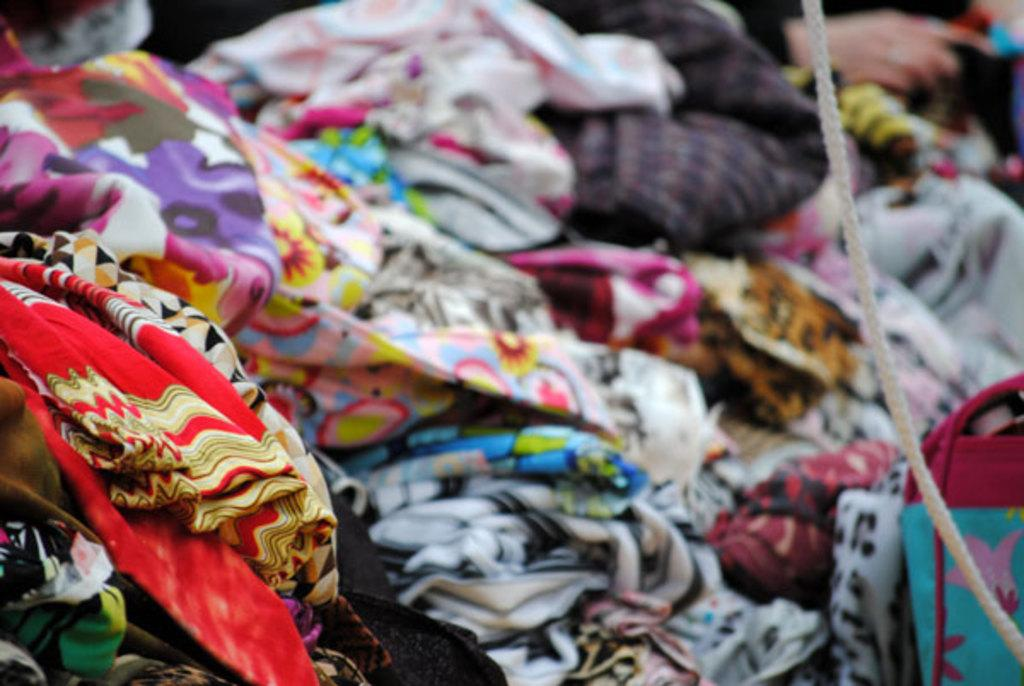What is present in the image that people wear? There are clothes in the image. How are the clothes arranged in the image? The clothes are stacked one upon the other. What other object can be seen in the image? There is a rope in the image. What statement does the woman make in the image? There is no woman present in the image, so no statement can be attributed to her. 